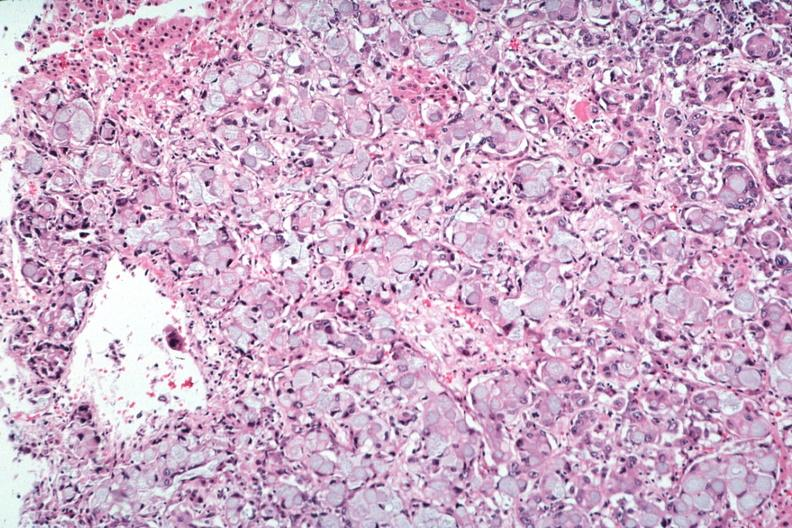where is this part in the figure?
Answer the question using a single word or phrase. Endocrine system 